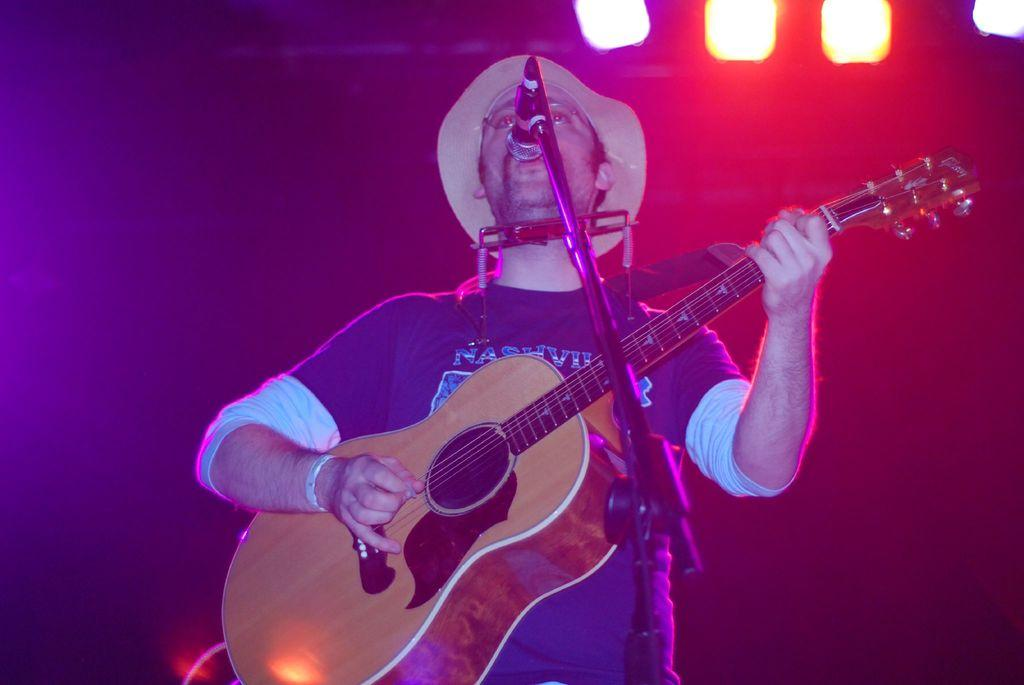What is the person in the image doing? The person is standing, holding a guitar, and singing. What object is the person holding in the image? The person is holding a guitar. What is the person using to amplify their voice in the image? There is a microphone with a stand in the image. What can be seen in the background of the image? There are focusing lights in the background of the image. What type of bread is being used to start a fire in the image? There is no bread or fire present in the image. 